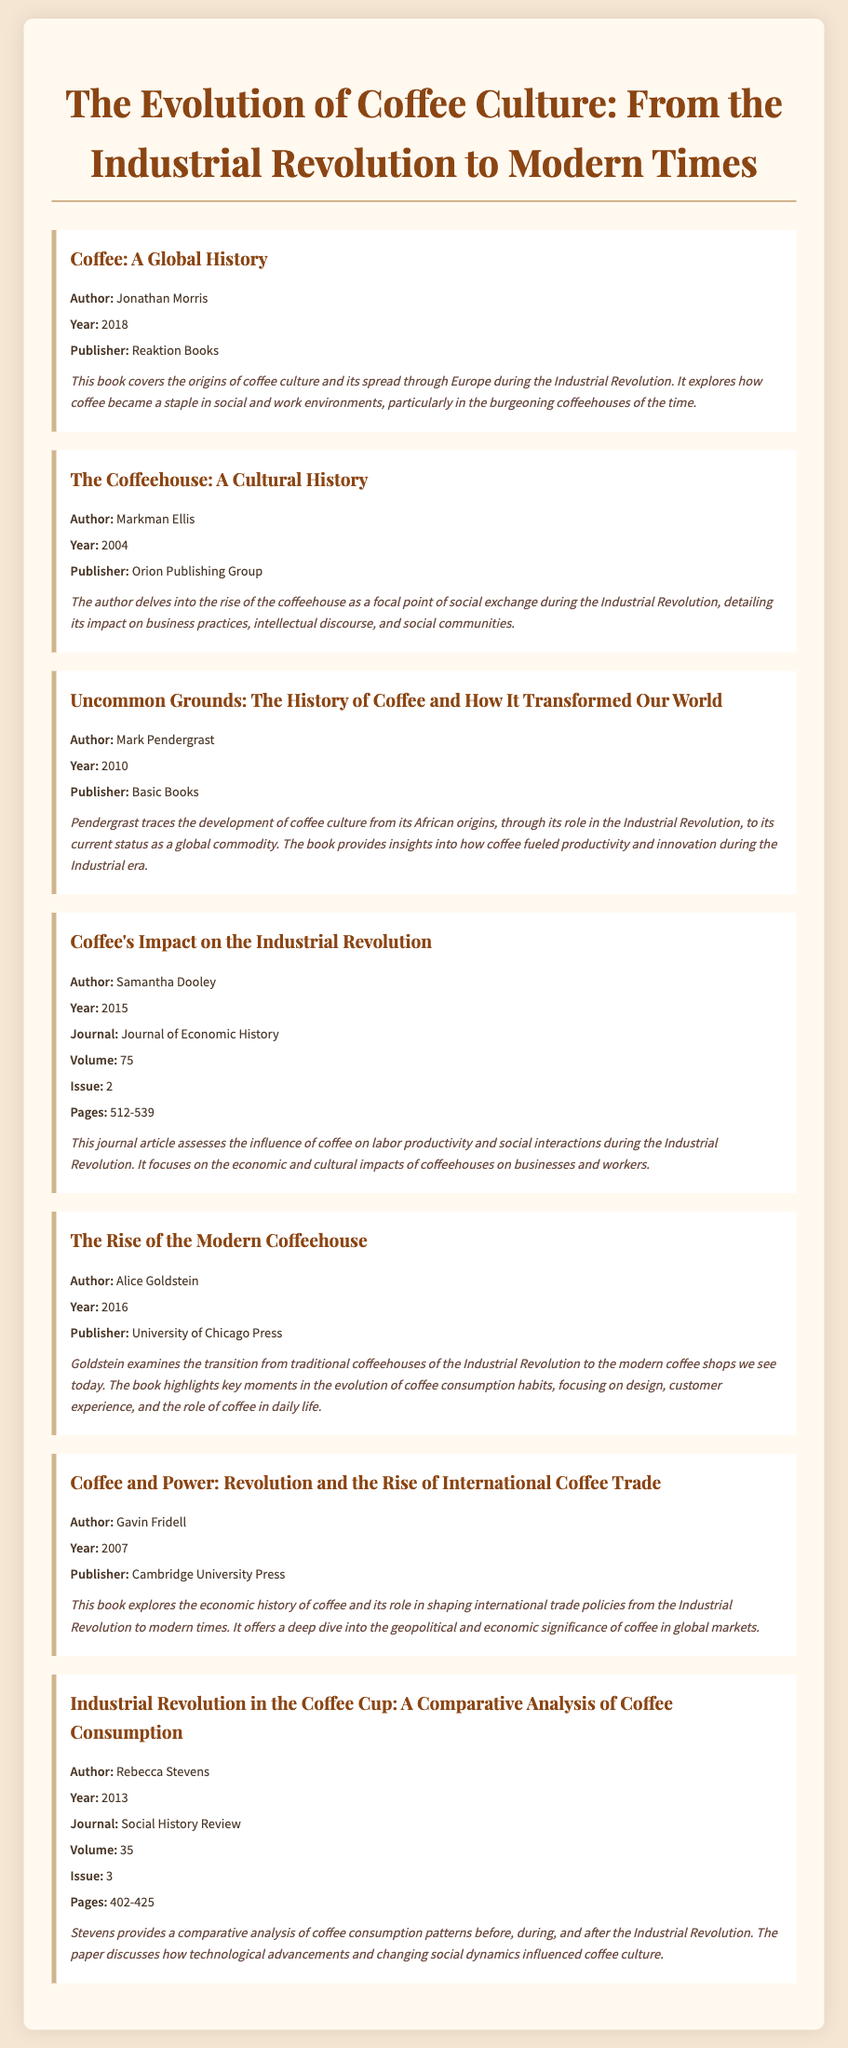What is the title of the first book listed? The title of the first book can be found at the beginning of the first bibliography item.
Answer: Coffee: A Global History Who is the author of "The Coffeehouse: A Cultural History"? The author's name is mentioned directly under the title in its corresponding bibliography item.
Answer: Markman Ellis In what year was "Uncommon Grounds" published? The publication year is provided in the bibliography entry for "Uncommon Grounds".
Answer: 2010 What is the journal name for Samantha Dooley's article? The journal name can be identified in the bibliographic details of Dooley's article.
Answer: Journal of Economic History Which book discusses the transition from traditional coffeehouses to modern coffee shops? The content of the bibliography item highlights its focus in the description section.
Answer: The Rise of the Modern Coffeehouse How many pages does Samantha Dooley's article cover? The page range is mentioned in the bibliographic entry for her journal article.
Answer: 512-539 What publisher released "Coffee and Power"? The publisher's name is located in the bibliographic details for Fridell's book.
Answer: Cambridge University Press What is the volume number of the journal where "Industrial Revolution in the Coffee Cup" was published? The volume number is stated in the bibliographic entry for the article.
Answer: 35 